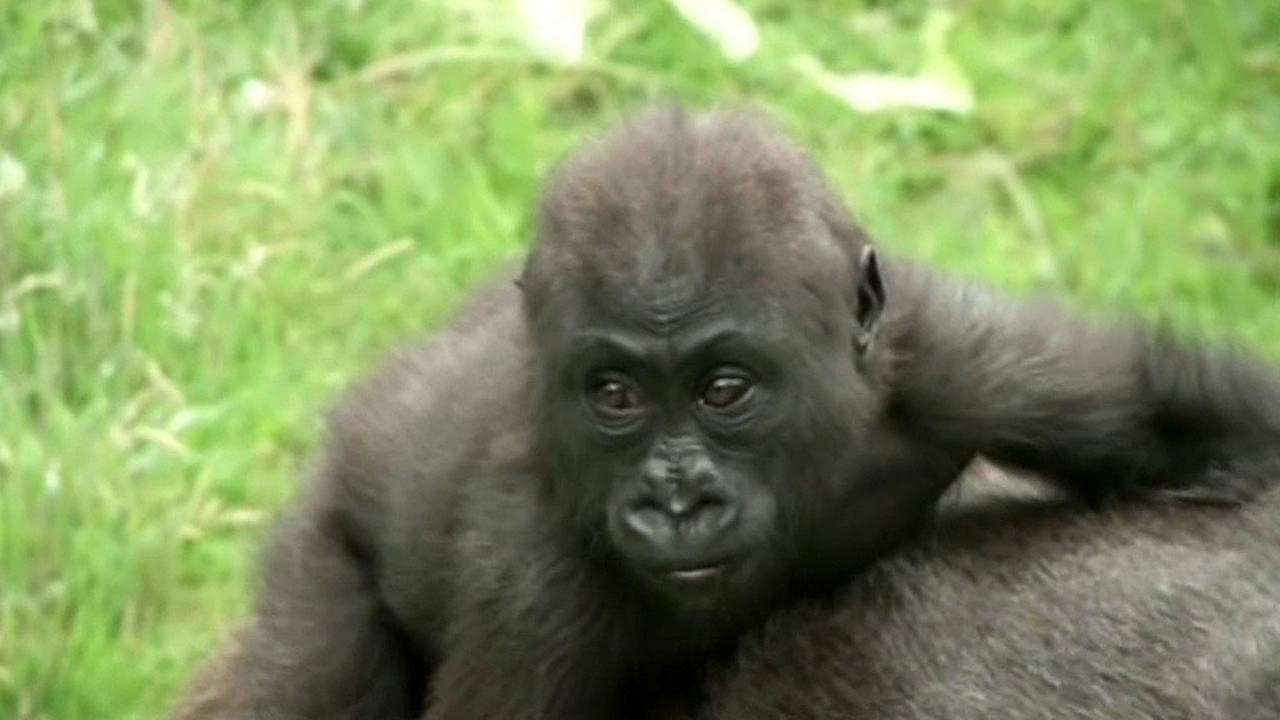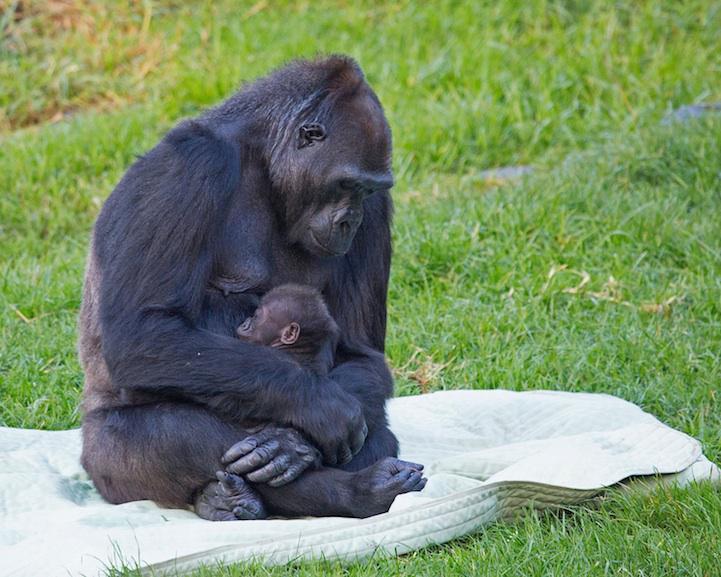The first image is the image on the left, the second image is the image on the right. For the images displayed, is the sentence "There are parts of at least four gorillas visible." factually correct? Answer yes or no. Yes. The first image is the image on the left, the second image is the image on the right. Considering the images on both sides, is "An image shows a gorilla sitting and holding a baby animal to its chest." valid? Answer yes or no. Yes. 